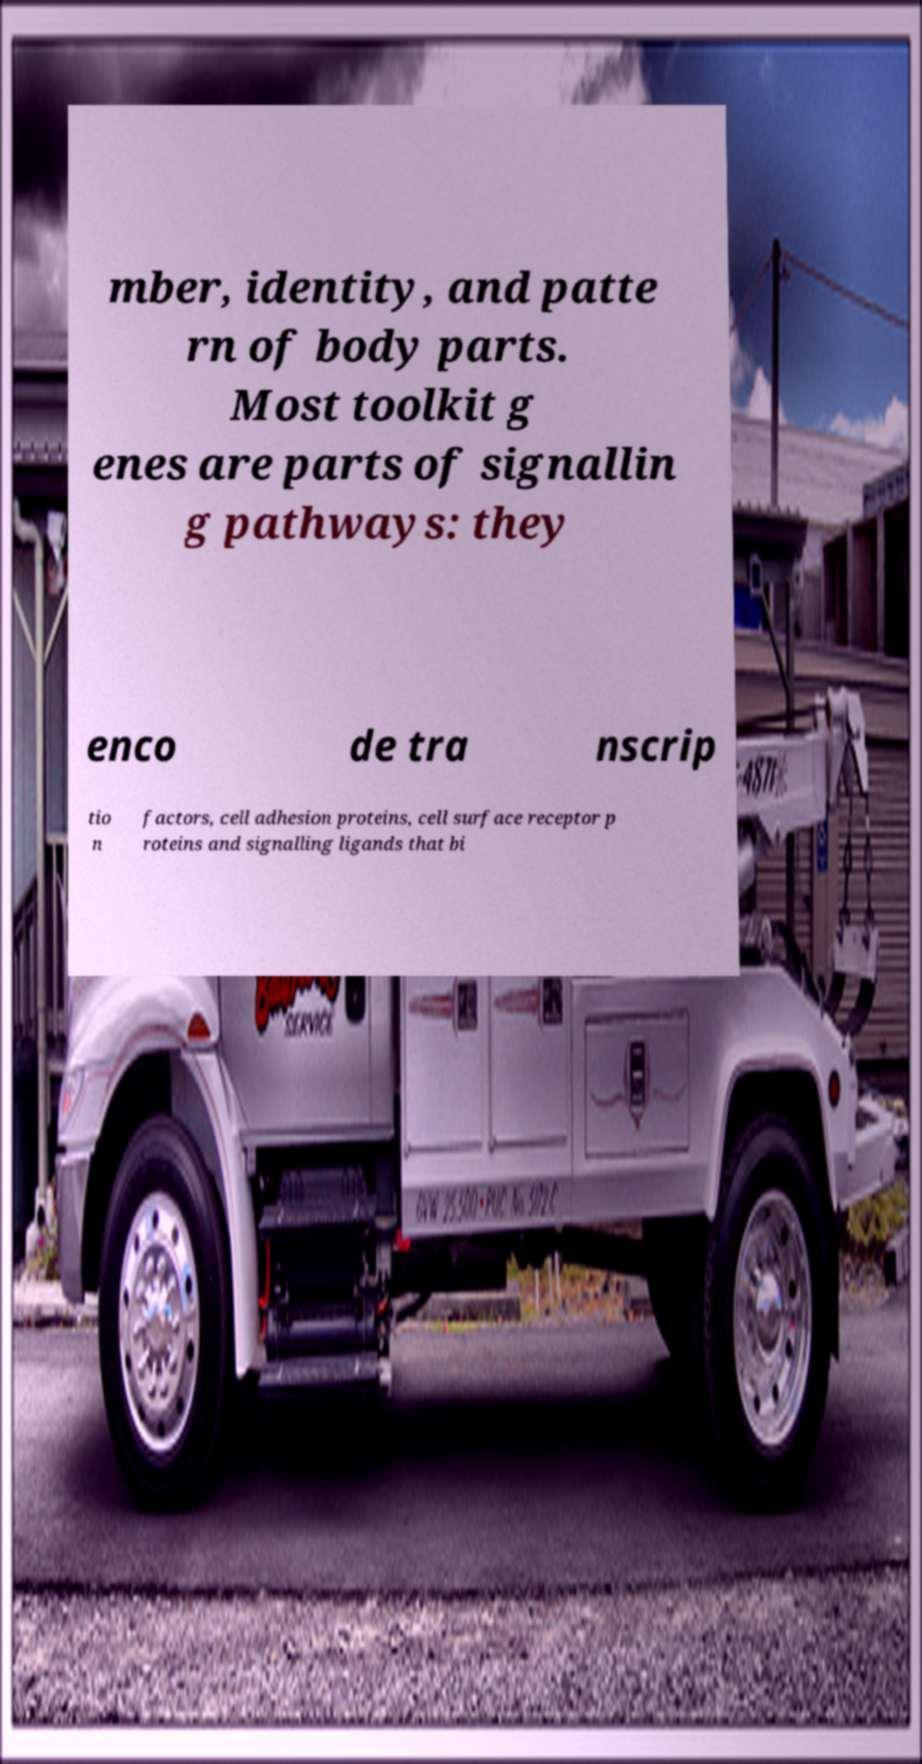Please read and relay the text visible in this image. What does it say? mber, identity, and patte rn of body parts. Most toolkit g enes are parts of signallin g pathways: they enco de tra nscrip tio n factors, cell adhesion proteins, cell surface receptor p roteins and signalling ligands that bi 